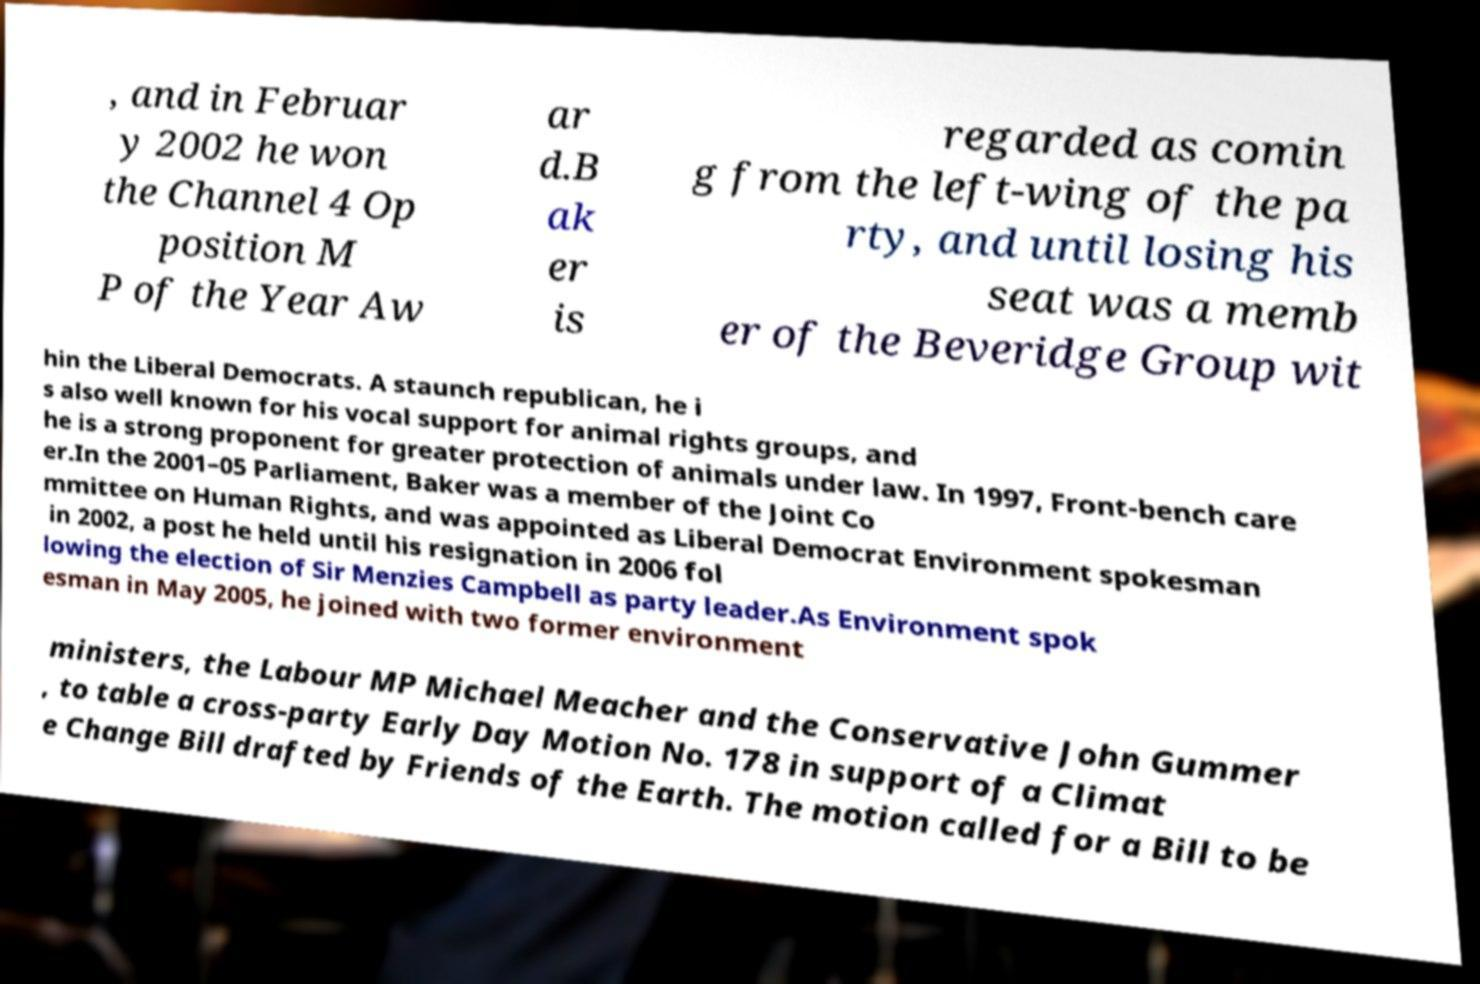What messages or text are displayed in this image? I need them in a readable, typed format. , and in Februar y 2002 he won the Channel 4 Op position M P of the Year Aw ar d.B ak er is regarded as comin g from the left-wing of the pa rty, and until losing his seat was a memb er of the Beveridge Group wit hin the Liberal Democrats. A staunch republican, he i s also well known for his vocal support for animal rights groups, and he is a strong proponent for greater protection of animals under law. In 1997, Front-bench care er.In the 2001–05 Parliament, Baker was a member of the Joint Co mmittee on Human Rights, and was appointed as Liberal Democrat Environment spokesman in 2002, a post he held until his resignation in 2006 fol lowing the election of Sir Menzies Campbell as party leader.As Environment spok esman in May 2005, he joined with two former environment ministers, the Labour MP Michael Meacher and the Conservative John Gummer , to table a cross-party Early Day Motion No. 178 in support of a Climat e Change Bill drafted by Friends of the Earth. The motion called for a Bill to be 